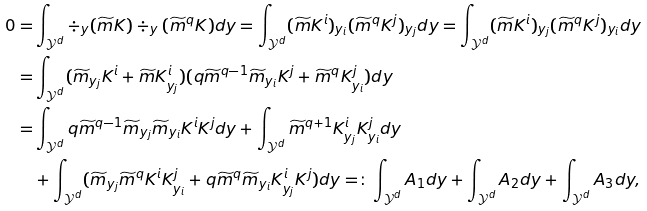Convert formula to latex. <formula><loc_0><loc_0><loc_500><loc_500>0 = & \int _ { \mathcal { Y } ^ { d } } \div _ { y } ( \widetilde { m } K ) \div _ { y } ( \widetilde { m } ^ { q } K ) d y = \int _ { \mathcal { Y } ^ { d } } ( \widetilde { m } K ^ { i } ) _ { y _ { i } } ( \widetilde { m } ^ { q } K ^ { j } ) _ { y _ { j } } d y = \int _ { \mathcal { Y } ^ { d } } ( \widetilde { m } K ^ { i } ) _ { y _ { j } } ( \widetilde { m } ^ { q } K ^ { j } ) _ { y _ { i } } d y \\ = & \int _ { \mathcal { Y } ^ { d } } ( \widetilde { m } _ { y _ { j } } K ^ { i } + \widetilde { m } K ^ { i } _ { y _ { j } } ) ( q \widetilde { m } ^ { q - 1 } \widetilde { m } _ { y _ { i } } K ^ { j } + \widetilde { m } ^ { q } K ^ { j } _ { y _ { i } } ) d y \\ = & \int _ { \mathcal { Y } ^ { d } } q \widetilde { m } ^ { q - 1 } \widetilde { m } _ { y _ { j } } \widetilde { m } _ { y _ { i } } K ^ { i } K ^ { j } d y + \int _ { \mathcal { Y } ^ { d } } \widetilde { m } ^ { q + 1 } K ^ { i } _ { y _ { j } } K ^ { j } _ { y _ { i } } d y \\ & + \int _ { \mathcal { Y } ^ { d } } ( \widetilde { m } _ { y _ { j } } \widetilde { m } ^ { q } K ^ { i } K ^ { j } _ { y _ { i } } + q \widetilde { m } ^ { q } \widetilde { m } _ { y _ { i } } K ^ { i } _ { y _ { j } } K ^ { j } ) d y = \colon \int _ { \mathcal { Y } ^ { d } } A _ { 1 } d y + \int _ { \mathcal { Y } ^ { d } } A _ { 2 } d y + \int _ { \mathcal { Y } ^ { d } } A _ { 3 } d y ,</formula> 